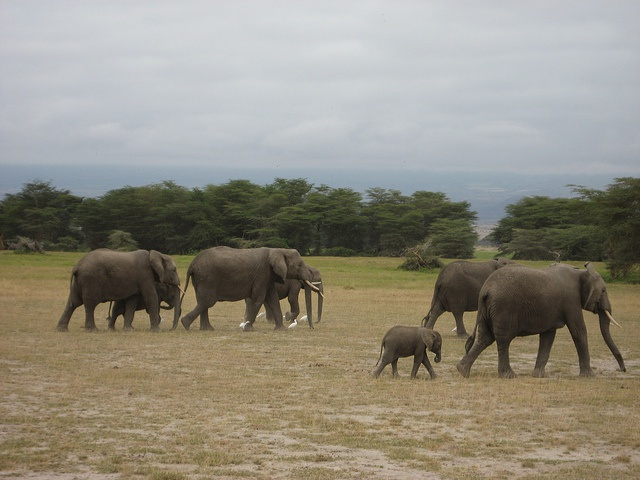Describe the objects in this image and their specific colors. I can see elephant in lightgray, black, and gray tones, elephant in lightgray, black, and gray tones, elephant in lightgray, black, and gray tones, elephant in lightgray, black, and gray tones, and elephant in lightgray, black, and gray tones in this image. 